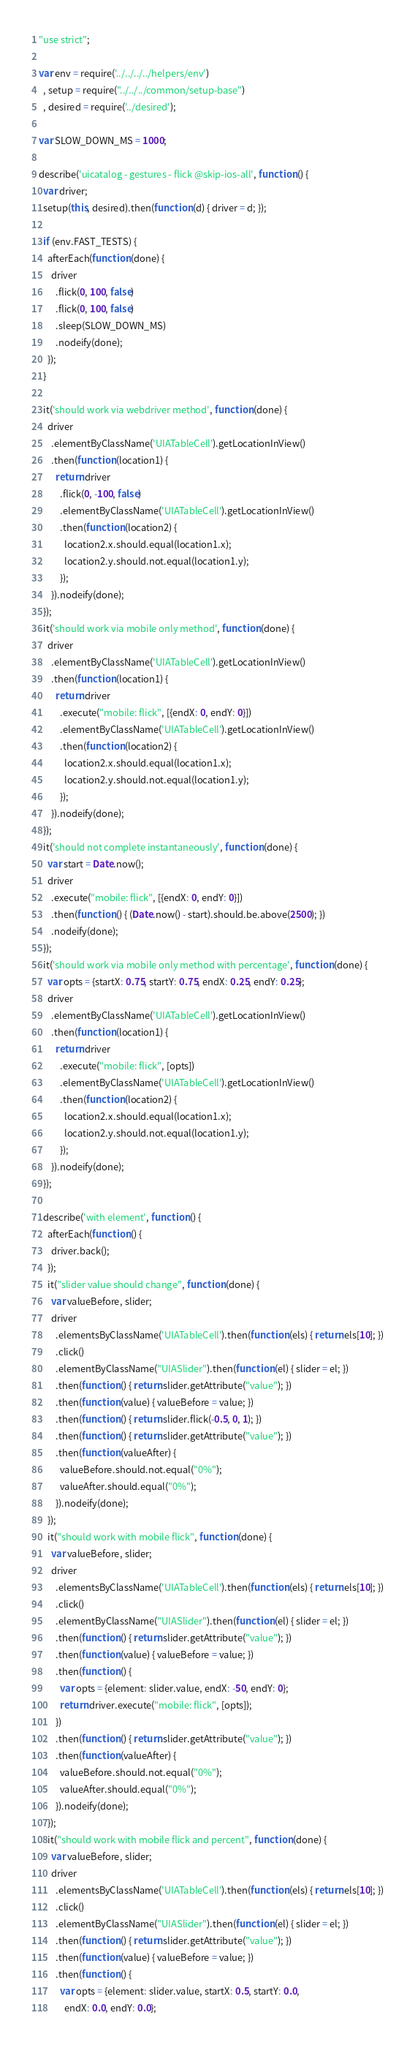Convert code to text. <code><loc_0><loc_0><loc_500><loc_500><_JavaScript_>"use strict";

var env = require('../../../../helpers/env')
  , setup = require("../../../common/setup-base")
  , desired = require('../desired');

var SLOW_DOWN_MS = 1000;

describe('uicatalog - gestures - flick @skip-ios-all', function () {
  var driver;
  setup(this, desired).then(function (d) { driver = d; });

  if (env.FAST_TESTS) {
    afterEach(function (done) {
      driver
        .flick(0, 100, false)
        .flick(0, 100, false)
        .sleep(SLOW_DOWN_MS)
        .nodeify(done);
    });
  }

  it('should work via webdriver method', function (done) {
    driver
      .elementByClassName('UIATableCell').getLocationInView()
      .then(function (location1) {
        return driver
          .flick(0, -100, false)
          .elementByClassName('UIATableCell').getLocationInView()
          .then(function (location2) {
            location2.x.should.equal(location1.x);
            location2.y.should.not.equal(location1.y);
          });
      }).nodeify(done);
  });
  it('should work via mobile only method', function (done) {
    driver
      .elementByClassName('UIATableCell').getLocationInView()
      .then(function (location1) {
        return driver
          .execute("mobile: flick", [{endX: 0, endY: 0}])
          .elementByClassName('UIATableCell').getLocationInView()
          .then(function (location2) {
            location2.x.should.equal(location1.x);
            location2.y.should.not.equal(location1.y);
          });
      }).nodeify(done);
  });
  it('should not complete instantaneously', function (done) {
    var start = Date.now();
    driver
      .execute("mobile: flick", [{endX: 0, endY: 0}])
      .then(function () { (Date.now() - start).should.be.above(2500); })
      .nodeify(done);
  });
  it('should work via mobile only method with percentage', function (done) {
    var opts = {startX: 0.75, startY: 0.75, endX: 0.25, endY: 0.25};
    driver
      .elementByClassName('UIATableCell').getLocationInView()
      .then(function (location1) {
        return driver
          .execute("mobile: flick", [opts])
          .elementByClassName('UIATableCell').getLocationInView()
          .then(function (location2) {
            location2.x.should.equal(location1.x);
            location2.y.should.not.equal(location1.y);
          });
      }).nodeify(done);
  });

  describe('with element', function () {
    afterEach(function () {
      driver.back();
    });
    it("slider value should change", function (done) {
      var valueBefore, slider;
      driver
        .elementsByClassName('UIATableCell').then(function (els) { return els[10]; })
        .click()
        .elementByClassName("UIASlider").then(function (el) { slider = el; })
        .then(function () { return slider.getAttribute("value"); })
        .then(function (value) { valueBefore = value; })
        .then(function () { return slider.flick(-0.5, 0, 1); })
        .then(function () { return slider.getAttribute("value"); })
        .then(function (valueAfter) {
          valueBefore.should.not.equal("0%");
          valueAfter.should.equal("0%");
        }).nodeify(done);
    });
    it("should work with mobile flick", function (done) {
      var valueBefore, slider;
      driver
        .elementsByClassName('UIATableCell').then(function (els) { return els[10]; })
        .click()
        .elementByClassName("UIASlider").then(function (el) { slider = el; })
        .then(function () { return slider.getAttribute("value"); })
        .then(function (value) { valueBefore = value; })
        .then(function () {
          var opts = {element: slider.value, endX: -50, endY: 0};
          return driver.execute("mobile: flick", [opts]);
        })
        .then(function () { return slider.getAttribute("value"); })
        .then(function (valueAfter) {
          valueBefore.should.not.equal("0%");
          valueAfter.should.equal("0%");
        }).nodeify(done);
    });
    it("should work with mobile flick and percent", function (done) {
      var valueBefore, slider;
      driver
        .elementsByClassName('UIATableCell').then(function (els) { return els[10]; })
        .click()
        .elementByClassName("UIASlider").then(function (el) { slider = el; })
        .then(function () { return slider.getAttribute("value"); })
        .then(function (value) { valueBefore = value; })
        .then(function () {
          var opts = {element: slider.value, startX: 0.5, startY: 0.0,
            endX: 0.0, endY: 0.0};</code> 